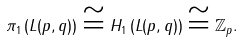<formula> <loc_0><loc_0><loc_500><loc_500>\pi _ { 1 } \left ( L ( p , q ) \right ) \cong H _ { 1 } \left ( L ( p , q ) \right ) \cong \mathbb { Z } _ { p } .</formula> 